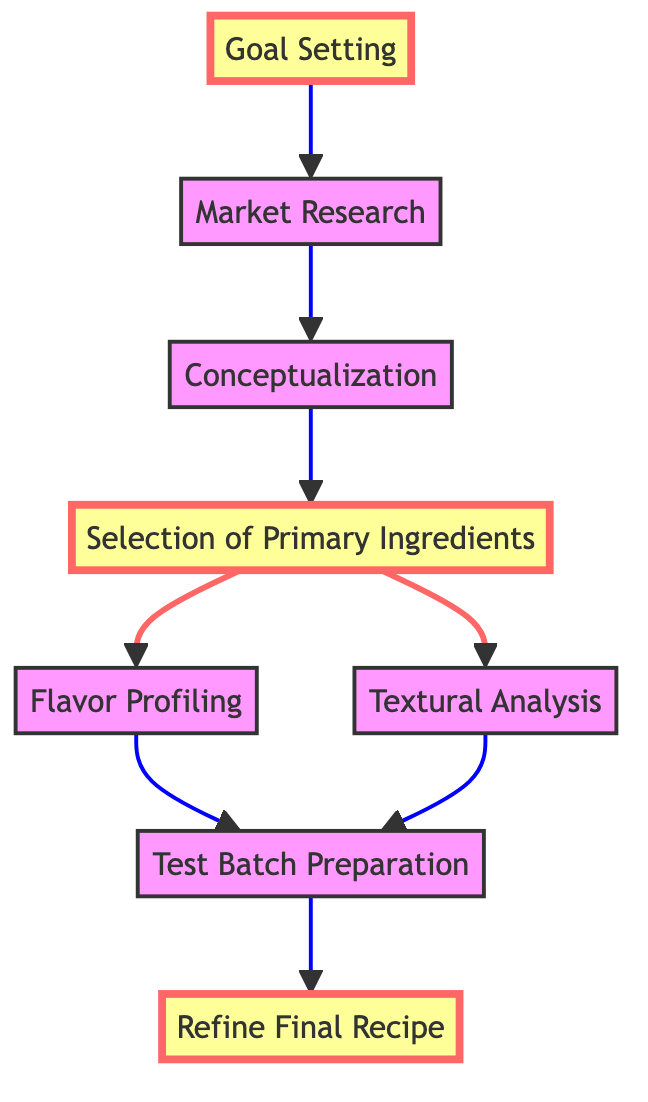What is the first step in the pastry recipe development process? The first step in the diagram is "Goal Setting," which defines what type of pastry is being created and its desired characteristics. It is located at the bottom of the flowchart, indicating it is the starting point of the process.
Answer: Goal Setting How many nodes are present in the flowchart? The flowchart contains a total of eight nodes, which represent different steps in developing a new pastry recipe. Each node is a distinct process or action within the overall flow.
Answer: Eight What step comes after "Selection of Primary Ingredients"? The step that follows "Selection of Primary Ingredients" is "Flavor Profiling," which involves analyzing flavor combinations, especially the unique aspects of farmer's cream. This relationship is directly indicated by the arrow from the selection node to the profiling node in the flowchart.
Answer: Flavor Profiling Which two steps lead to "Test Batch Preparation"? The steps that direct to "Test Batch Preparation" are "Flavor Profiling" and "Textural Analysis." The flowchart shows both of these processes connecting to the testing stage, indicating that they inform the preparation of test batches.
Answer: Flavor Profiling and Textural Analysis What is the last step in the flowchart? The last step stated in the flowchart is "Refine Final Recipe," which involves making final adjustments based on taste and texture tests. It is positioned at the top of the flowchart, indicating it concludes the process.
Answer: Refine Final Recipe How are "Market Research" and "Conceptualization" related? "Market Research" leads directly to "Conceptualization" in the flowchart. This indicates that the insights gained from researching the market inform the brainstorming and outlining of the pastry idea, placing "Conceptualization" as the next step after completing the market analysis.
Answer: Directly related What distinguishes the selection of ingredients in this process? The selection of ingredients emphasizes the use of "farmer's cream" for distinction, as noted in the description associated with the "Selection of Primary Ingredients" node. This highlights its importance in achieving unique flavor and texture profiles in the pastry.
Answer: Farmer's cream How many processes involve flavor or texture analysis in the diagram? Two processes are designated for flavor and texture analysis: "Flavor Profiling" and "Textural Analysis." Each of these processes examines critical aspects of the pastry development, ensuring both flavor and texture are addressed in the recipe creation.
Answer: Two 